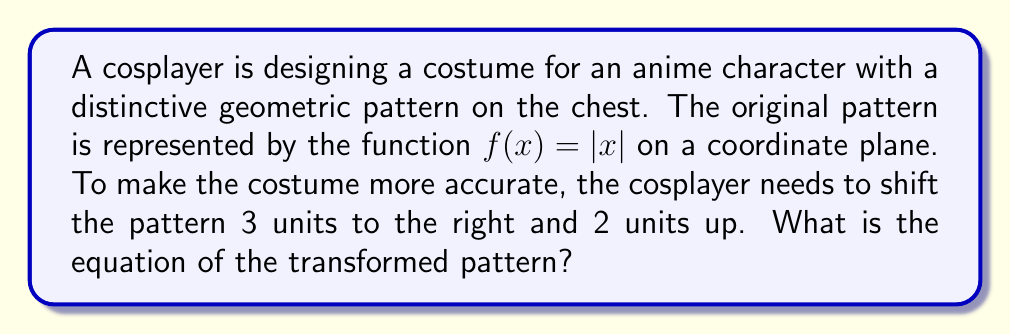Can you answer this question? To solve this problem, we need to apply a translation to the original function $f(x) = |x|$. 

1. Shifting 3 units to the right:
   This is represented by replacing every $x$ in the original function with $(x - 3)$.
   The function becomes: $f(x) = |x - 3|$

2. Shifting 2 units up:
   This is represented by adding 2 to the entire function.
   The function becomes: $f(x) = |x - 3| + 2$

Therefore, the final transformed function is $g(x) = |x - 3| + 2$.

To verify, let's consider a few points:
- The vertex of the original function $f(x) = |x|$ is at (0, 0).
- After the transformation, this point should be at (3, 2).
- We can check: $g(3) = |3 - 3| + 2 = 0 + 2 = 2$, which confirms the vertex is now at (3, 2).

The transformation can be visualized as follows:

[asy]
import graph;
size(200);
xaxis("x");
yaxis("y");

real f(real x) {return abs(x);}
real g(real x) {return abs(x-3)+2;}

draw(graph(f,-5,5),blue);
draw(graph(g,-2,8),red);

label("$f(x)$", (4,4), blue);
label("$g(x)$", (7,6), red);
[/asy]

The blue line represents the original function $f(x) = |x|$, and the red line represents the transformed function $g(x) = |x - 3| + 2$.
Answer: $g(x) = |x - 3| + 2$ 